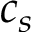<formula> <loc_0><loc_0><loc_500><loc_500>c _ { s }</formula> 